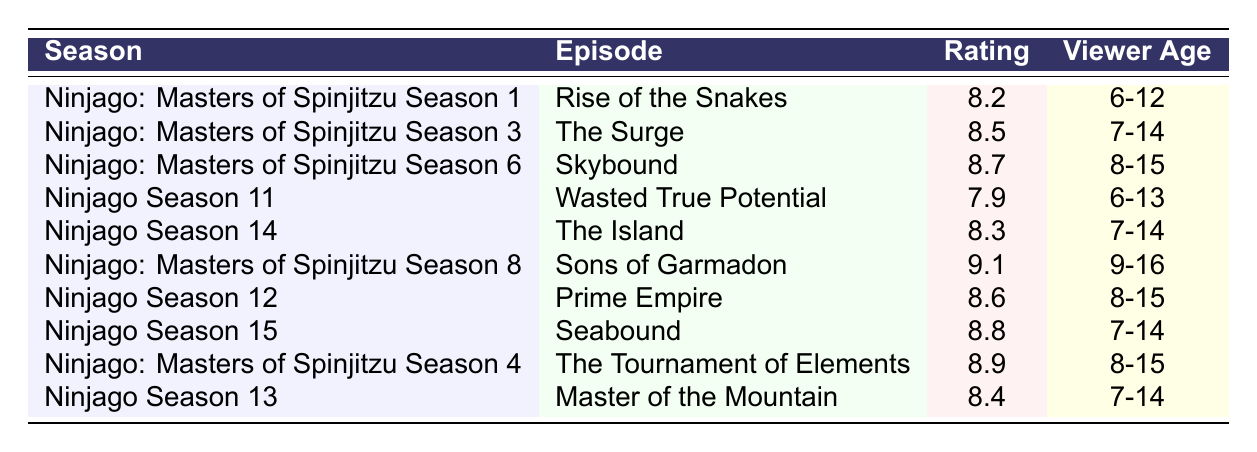What is the highest-rated episode in the table? The highest rating listed in the table is 9.1, which corresponds to the episode "Sons of Garmadon" in "Ninjago: Masters of Spinjitzu Season 8."
Answer: Sons of Garmadon Which episode has the lowest rating? The lowest rating listed in the table is 7.9, corresponding to "Wasted True Potential" in "Ninjago Season 11."
Answer: Wasted True Potential What is the average rating of episodes aimed at viewer ages 7-14? The episodes aimed at ages 7-14 are "The Surge" (8.5), "The Island" (8.3), "Seabound" (8.8), "Master of the Mountain" (8.4). Their sum is (8.5 + 8.3 + 8.8 + 8.4) = 34. The average is 34/4 = 8.5.
Answer: 8.5 Are there any episodes rated below 8.0? Yes, "Wasted True Potential" from "Ninjago Season 11" is rated 7.9, which is below 8.0.
Answer: Yes Which season has the episode with the highest rating, and what is that rating? The episode with the highest rating is "Sons of Garmadon" from "Ninjago: Masters of Spinjitzu Season 8," which has a rating of 9.1.
Answer: Ninjago: Masters of Spinjitzu Season 8, 9.1 What is the total number of episodes listed that are rated above 8.0? The episodes rated above 8.0 are "Rise of the Snakes" (8.2), "The Surge" (8.5), "Skybound" (8.7), "The Island" (8.3), "Sons of Garmadon" (9.1), "Prime Empire" (8.6), "Seabound" (8.8), "The Tournament of Elements" (8.9), and "Master of the Mountain" (8.4), totaling 9 episodes.
Answer: 9 Is there any episode with a rating of exactly 8.6? Yes, "Prime Empire" from "Ninjago Season 12" has a rating of exactly 8.6.
Answer: Yes List episodes with a rating of 8.5 or higher that target ages 8-15. The episodes that fit this criterion are "Skybound" (8.7), "Prime Empire" (8.6), "The Tournament of Elements" (8.9), "Seabound" (8.8), and "Sons of Garmadon" (9.1).
Answer: Skybound, Prime Empire, The Tournament of Elements, Seabound, Sons of Garmadon 